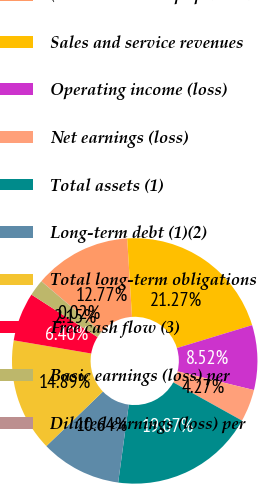Convert chart to OTSL. <chart><loc_0><loc_0><loc_500><loc_500><pie_chart><fcel>( in millions except per share<fcel>Sales and service revenues<fcel>Operating income (loss)<fcel>Net earnings (loss)<fcel>Total assets (1)<fcel>Long-term debt (1)(2)<fcel>Total long-term obligations<fcel>Free cash flow (3)<fcel>Basic earnings (loss) per<fcel>Diluted earnings (loss) per<nl><fcel>12.77%<fcel>21.27%<fcel>8.52%<fcel>4.27%<fcel>19.07%<fcel>10.64%<fcel>14.89%<fcel>6.4%<fcel>2.15%<fcel>0.02%<nl></chart> 